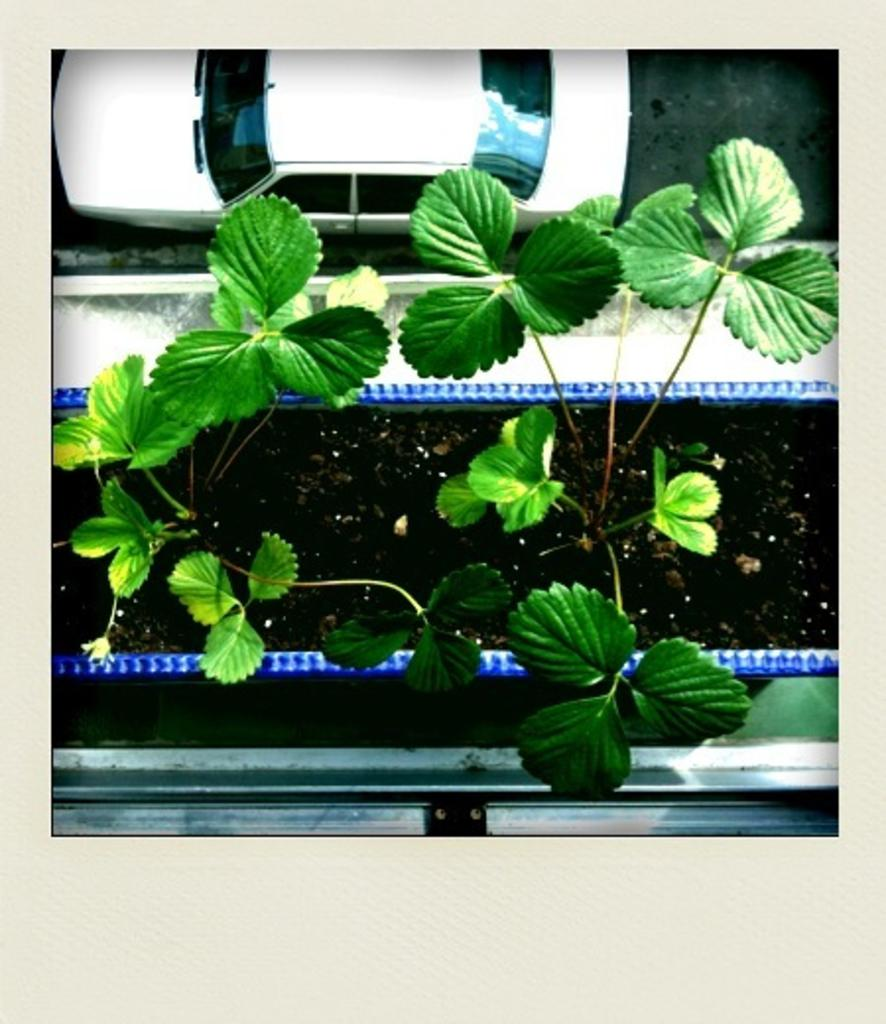What type of living organisms are in the image? There are plants on soil in the image. What type of vehicle can be seen on the road in the image? There is a car on the road in the image. What type of feather can be seen floating in the air in the image? There is no feather present in the image. What rhythm is the car on the road following in the image? The image does not provide information about the rhythm or speed of the car. 